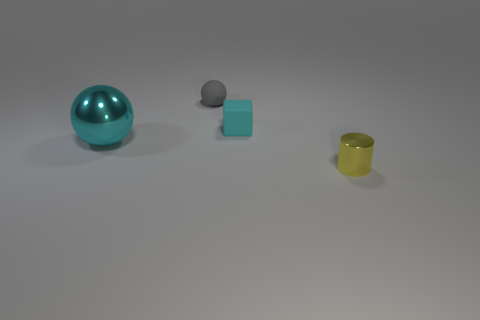Subtract all cylinders. How many objects are left? 3 Subtract all gray spheres. How many spheres are left? 1 Add 3 tiny gray things. How many objects exist? 7 Subtract 1 gray balls. How many objects are left? 3 Subtract 1 blocks. How many blocks are left? 0 Subtract all red blocks. Subtract all gray balls. How many blocks are left? 1 Subtract all blue cylinders. How many cyan spheres are left? 1 Subtract all matte blocks. Subtract all tiny purple metallic objects. How many objects are left? 3 Add 3 tiny balls. How many tiny balls are left? 4 Add 2 large yellow metal cylinders. How many large yellow metal cylinders exist? 2 